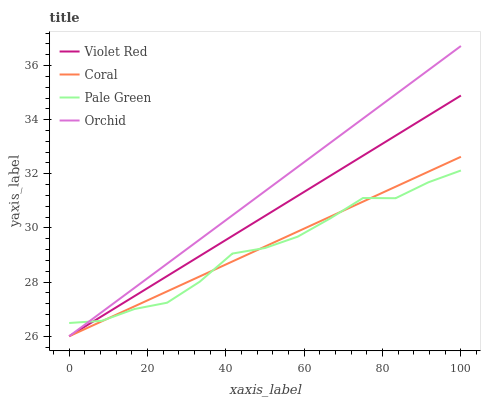Does Pale Green have the minimum area under the curve?
Answer yes or no. Yes. Does Orchid have the maximum area under the curve?
Answer yes or no. Yes. Does Coral have the minimum area under the curve?
Answer yes or no. No. Does Coral have the maximum area under the curve?
Answer yes or no. No. Is Violet Red the smoothest?
Answer yes or no. Yes. Is Pale Green the roughest?
Answer yes or no. Yes. Is Coral the smoothest?
Answer yes or no. No. Is Coral the roughest?
Answer yes or no. No. Does Violet Red have the lowest value?
Answer yes or no. Yes. Does Pale Green have the lowest value?
Answer yes or no. No. Does Orchid have the highest value?
Answer yes or no. Yes. Does Coral have the highest value?
Answer yes or no. No. Does Pale Green intersect Violet Red?
Answer yes or no. Yes. Is Pale Green less than Violet Red?
Answer yes or no. No. Is Pale Green greater than Violet Red?
Answer yes or no. No. 